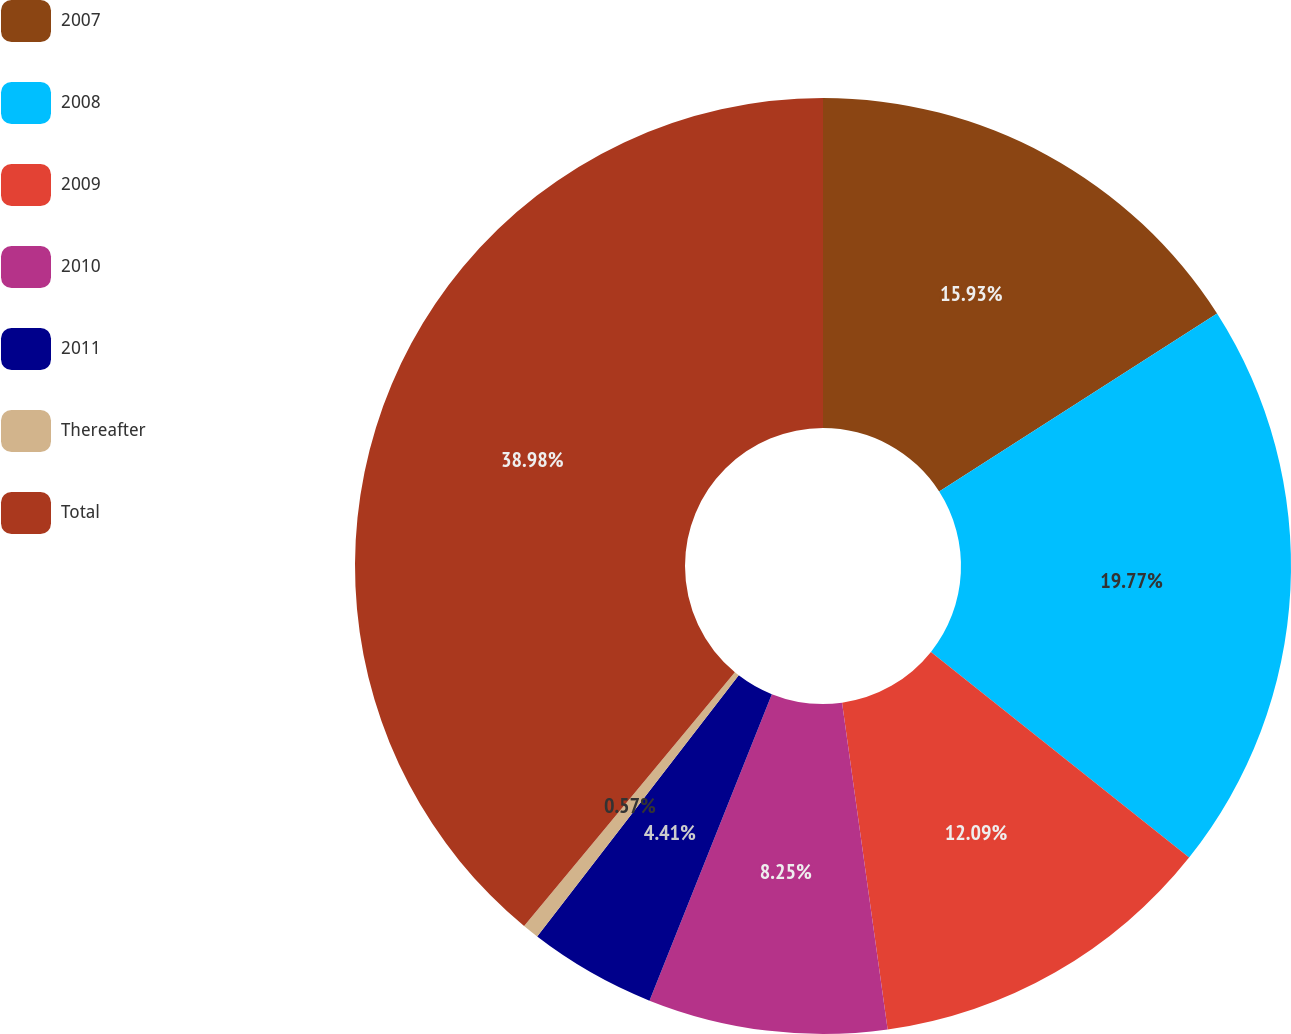Convert chart. <chart><loc_0><loc_0><loc_500><loc_500><pie_chart><fcel>2007<fcel>2008<fcel>2009<fcel>2010<fcel>2011<fcel>Thereafter<fcel>Total<nl><fcel>15.93%<fcel>19.77%<fcel>12.09%<fcel>8.25%<fcel>4.41%<fcel>0.57%<fcel>38.97%<nl></chart> 